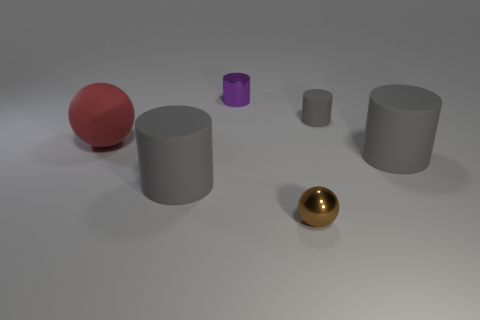Subtract all small metallic cylinders. How many cylinders are left? 3 Add 1 shiny things. How many objects exist? 7 Subtract all red spheres. How many spheres are left? 1 Subtract all green spheres. How many gray cylinders are left? 3 Subtract 2 balls. How many balls are left? 0 Subtract all red spheres. Subtract all gray cylinders. How many spheres are left? 1 Add 4 small spheres. How many small spheres are left? 5 Add 5 matte things. How many matte things exist? 9 Subtract 1 purple cylinders. How many objects are left? 5 Subtract all cylinders. How many objects are left? 2 